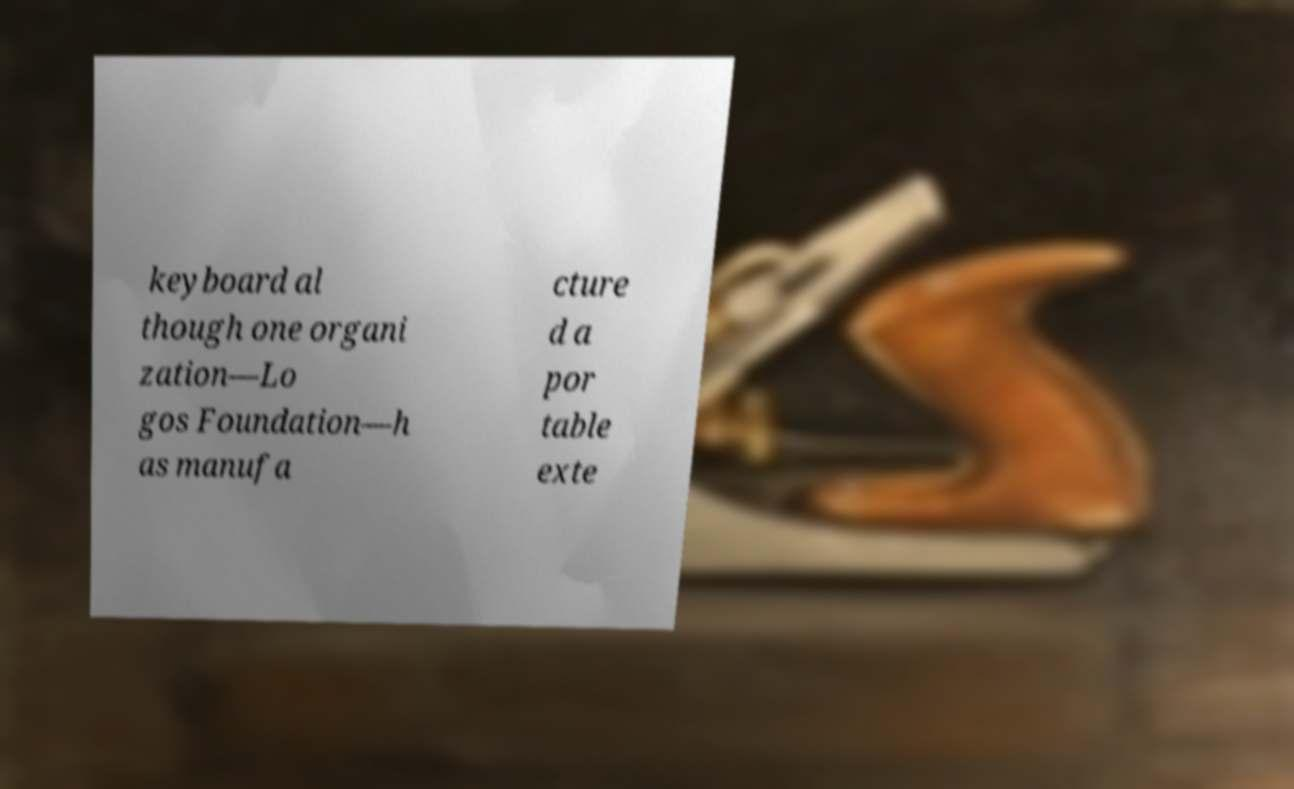There's text embedded in this image that I need extracted. Can you transcribe it verbatim? keyboard al though one organi zation—Lo gos Foundation—h as manufa cture d a por table exte 